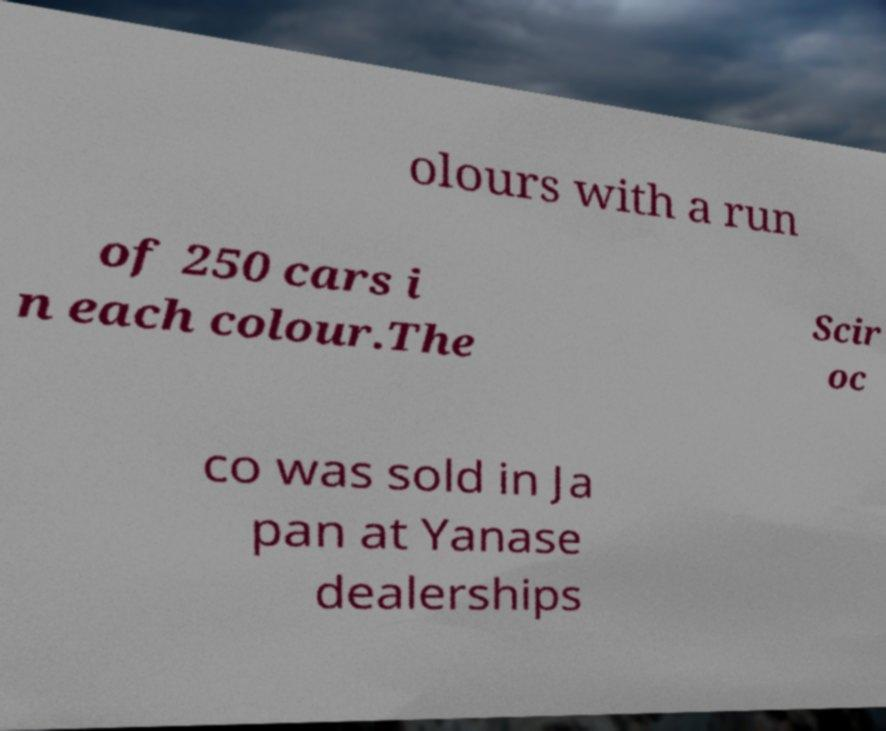I need the written content from this picture converted into text. Can you do that? olours with a run of 250 cars i n each colour.The Scir oc co was sold in Ja pan at Yanase dealerships 